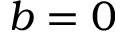Convert formula to latex. <formula><loc_0><loc_0><loc_500><loc_500>b = 0</formula> 